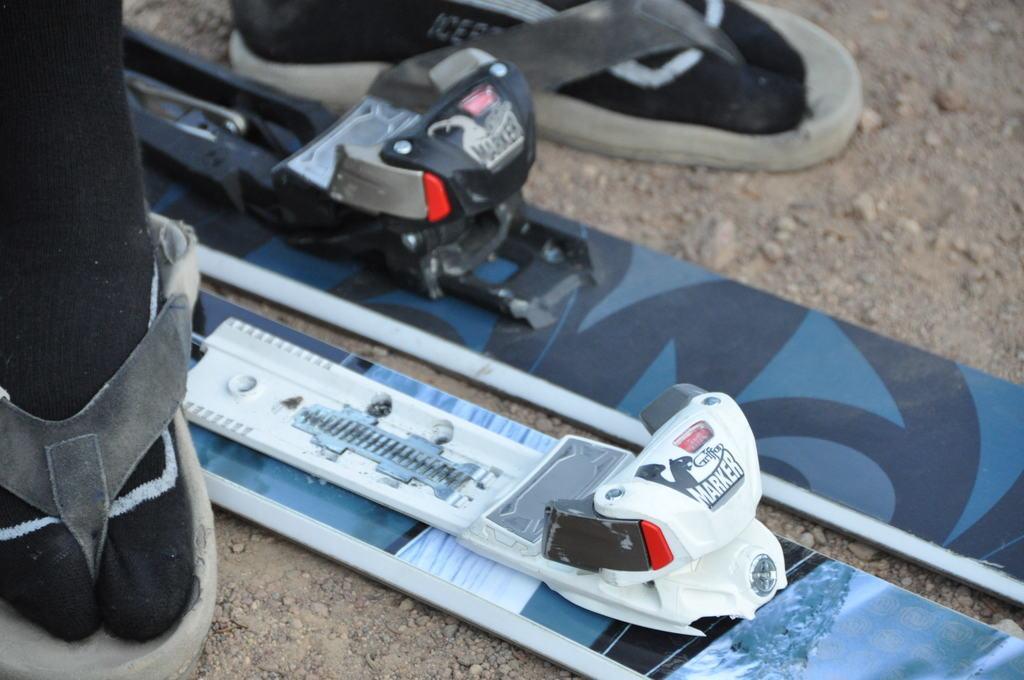Please provide a concise description of this image. In this image we can see persons legs wearing slippers. There are skiing boards. At the bottom of the image there is ground. 